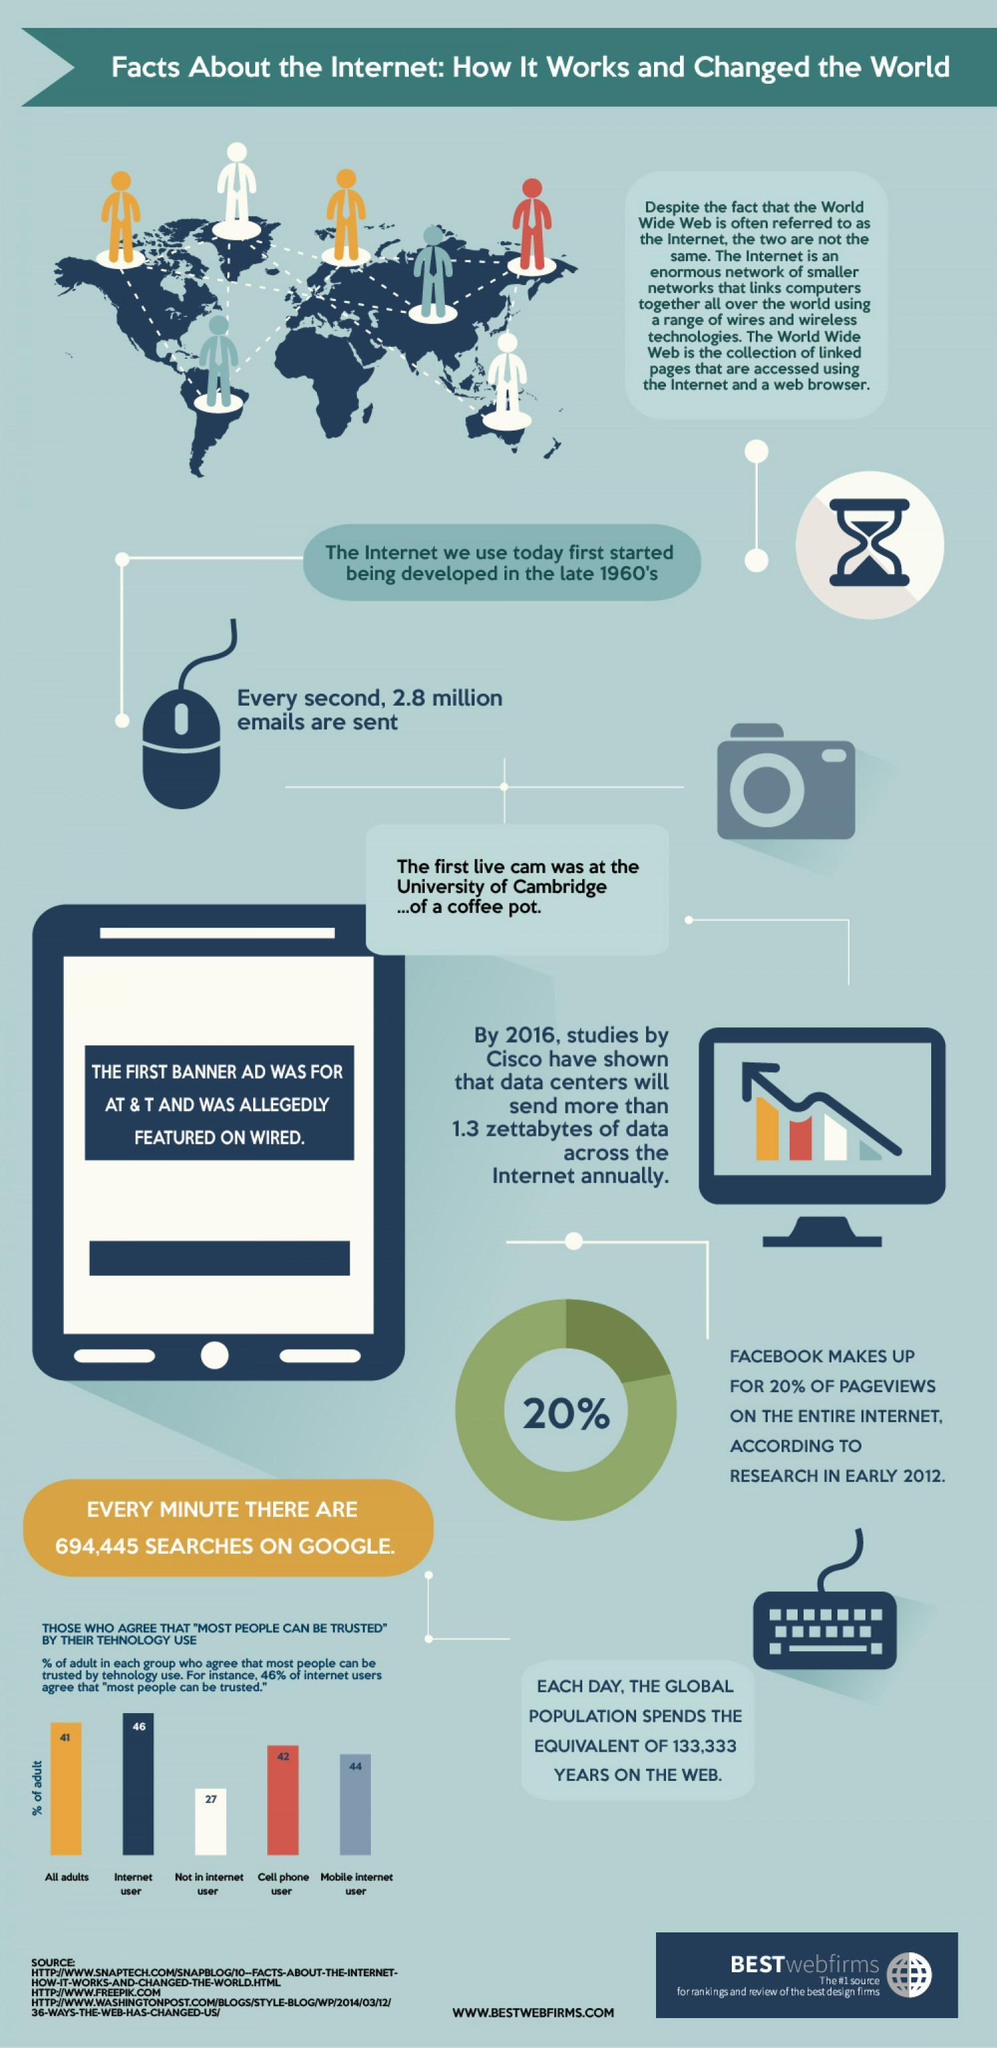How many people are in this infographic?
Answer the question with a short phrase. 7 How many numbers of camera or mouse is in this infographic? 2 